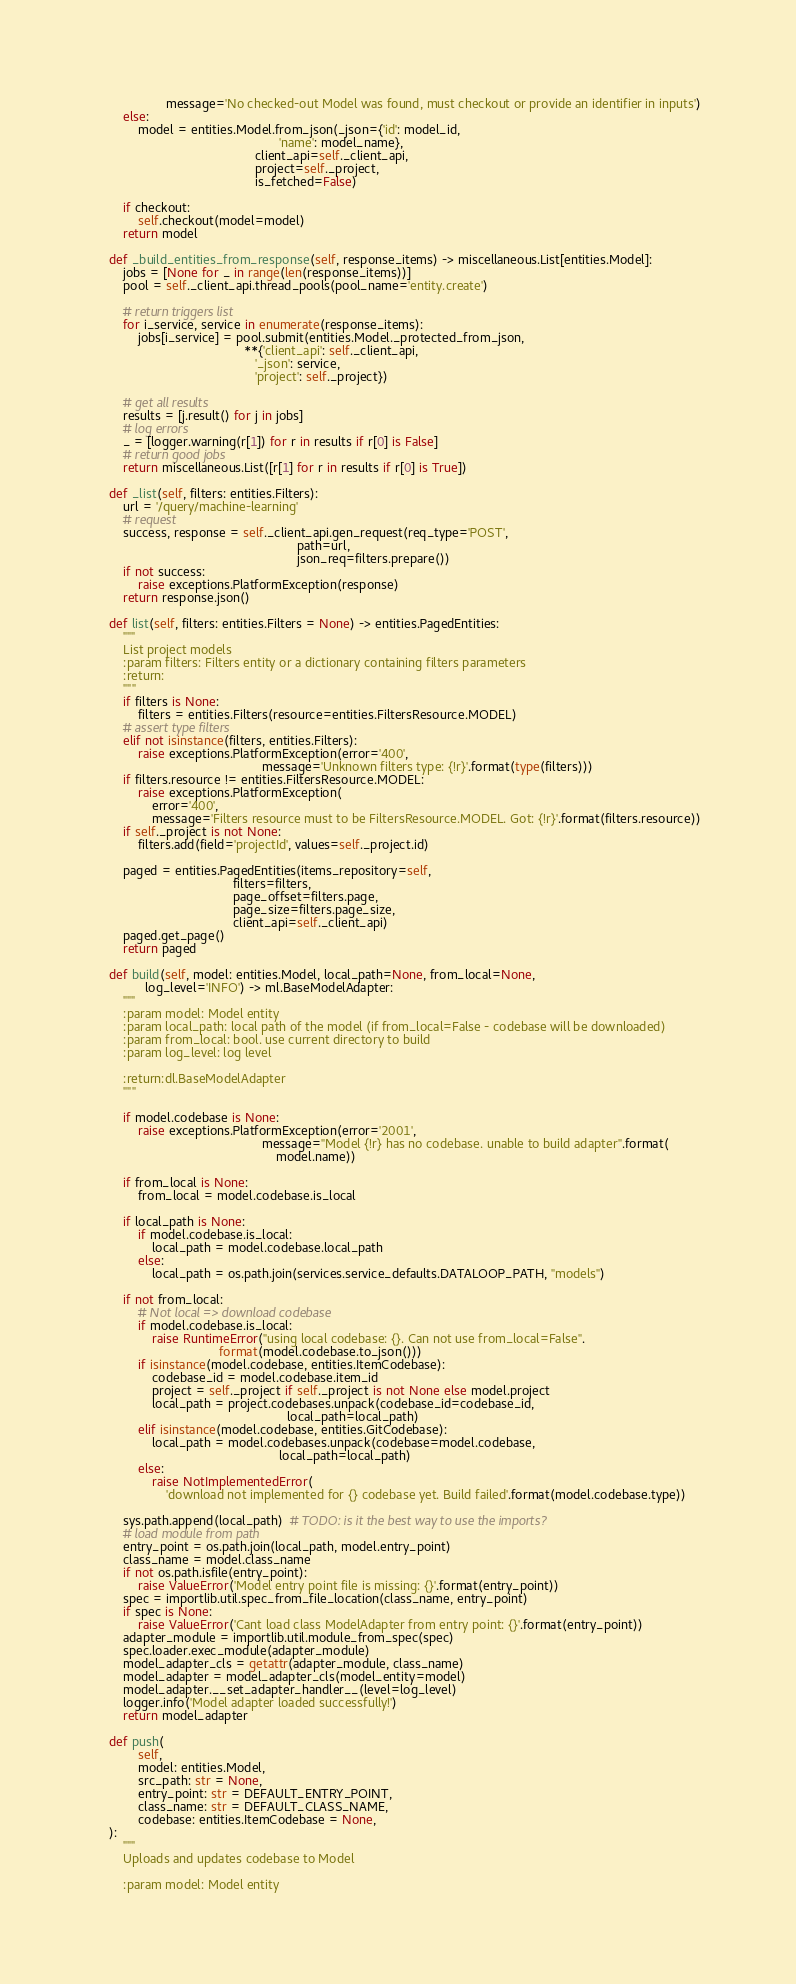Convert code to text. <code><loc_0><loc_0><loc_500><loc_500><_Python_>                    message='No checked-out Model was found, must checkout or provide an identifier in inputs')
        else:
            model = entities.Model.from_json(_json={'id': model_id,
                                                    'name': model_name},
                                             client_api=self._client_api,
                                             project=self._project,
                                             is_fetched=False)

        if checkout:
            self.checkout(model=model)
        return model

    def _build_entities_from_response(self, response_items) -> miscellaneous.List[entities.Model]:
        jobs = [None for _ in range(len(response_items))]
        pool = self._client_api.thread_pools(pool_name='entity.create')

        # return triggers list
        for i_service, service in enumerate(response_items):
            jobs[i_service] = pool.submit(entities.Model._protected_from_json,
                                          **{'client_api': self._client_api,
                                             '_json': service,
                                             'project': self._project})

        # get all results
        results = [j.result() for j in jobs]
        # log errors
        _ = [logger.warning(r[1]) for r in results if r[0] is False]
        # return good jobs
        return miscellaneous.List([r[1] for r in results if r[0] is True])

    def _list(self, filters: entities.Filters):
        url = '/query/machine-learning'
        # request
        success, response = self._client_api.gen_request(req_type='POST',
                                                         path=url,
                                                         json_req=filters.prepare())
        if not success:
            raise exceptions.PlatformException(response)
        return response.json()

    def list(self, filters: entities.Filters = None) -> entities.PagedEntities:
        """
        List project models
        :param filters: Filters entity or a dictionary containing filters parameters
        :return:
        """
        if filters is None:
            filters = entities.Filters(resource=entities.FiltersResource.MODEL)
        # assert type filters
        elif not isinstance(filters, entities.Filters):
            raise exceptions.PlatformException(error='400',
                                               message='Unknown filters type: {!r}'.format(type(filters)))
        if filters.resource != entities.FiltersResource.MODEL:
            raise exceptions.PlatformException(
                error='400',
                message='Filters resource must to be FiltersResource.MODEL. Got: {!r}'.format(filters.resource))
        if self._project is not None:
            filters.add(field='projectId', values=self._project.id)

        paged = entities.PagedEntities(items_repository=self,
                                       filters=filters,
                                       page_offset=filters.page,
                                       page_size=filters.page_size,
                                       client_api=self._client_api)
        paged.get_page()
        return paged

    def build(self, model: entities.Model, local_path=None, from_local=None,
              log_level='INFO') -> ml.BaseModelAdapter:
        """
        :param model: Model entity
        :param local_path: local path of the model (if from_local=False - codebase will be downloaded)
        :param from_local: bool. use current directory to build
        :param log_level: log level

        :return:dl.BaseModelAdapter
        """

        if model.codebase is None:
            raise exceptions.PlatformException(error='2001',
                                               message="Model {!r} has no codebase. unable to build adapter".format(
                                                   model.name))

        if from_local is None:
            from_local = model.codebase.is_local

        if local_path is None:
            if model.codebase.is_local:
                local_path = model.codebase.local_path
            else:
                local_path = os.path.join(services.service_defaults.DATALOOP_PATH, "models")

        if not from_local:
            # Not local => download codebase
            if model.codebase.is_local:
                raise RuntimeError("using local codebase: {}. Can not use from_local=False".
                                   format(model.codebase.to_json()))
            if isinstance(model.codebase, entities.ItemCodebase):
                codebase_id = model.codebase.item_id
                project = self._project if self._project is not None else model.project
                local_path = project.codebases.unpack(codebase_id=codebase_id,
                                                      local_path=local_path)
            elif isinstance(model.codebase, entities.GitCodebase):
                local_path = model.codebases.unpack(codebase=model.codebase,
                                                    local_path=local_path)
            else:
                raise NotImplementedError(
                    'download not implemented for {} codebase yet. Build failed'.format(model.codebase.type))

        sys.path.append(local_path)  # TODO: is it the best way to use the imports?
        # load module from path
        entry_point = os.path.join(local_path, model.entry_point)
        class_name = model.class_name
        if not os.path.isfile(entry_point):
            raise ValueError('Model entry point file is missing: {}'.format(entry_point))
        spec = importlib.util.spec_from_file_location(class_name, entry_point)
        if spec is None:
            raise ValueError('Cant load class ModelAdapter from entry point: {}'.format(entry_point))
        adapter_module = importlib.util.module_from_spec(spec)
        spec.loader.exec_module(adapter_module)
        model_adapter_cls = getattr(adapter_module, class_name)
        model_adapter = model_adapter_cls(model_entity=model)
        model_adapter.__set_adapter_handler__(level=log_level)
        logger.info('Model adapter loaded successfully!')
        return model_adapter

    def push(
            self,
            model: entities.Model,
            src_path: str = None,
            entry_point: str = DEFAULT_ENTRY_POINT,
            class_name: str = DEFAULT_CLASS_NAME,
            codebase: entities.ItemCodebase = None,
    ):
        """
        Uploads and updates codebase to Model

        :param model: Model entity</code> 